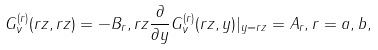Convert formula to latex. <formula><loc_0><loc_0><loc_500><loc_500>G _ { \nu } ^ { ( r ) } ( r z , r z ) = - B _ { r } , r z \frac { \partial } { \partial y } G _ { \nu } ^ { ( r ) } ( r z , y ) | _ { y = r z } = A _ { r } , r = a , b ,</formula> 